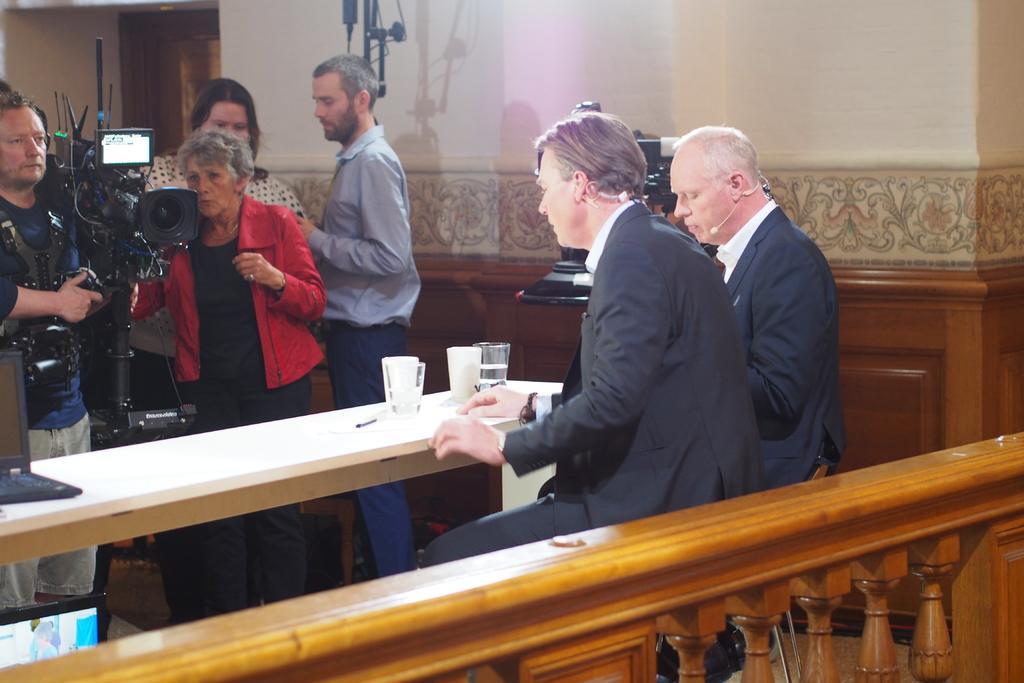In one or two sentences, can you explain what this image depicts? In the foreground of this image, on the bottom, there is a wooden railing. In the middle, there are two men wearing suits and sitting on the chairs and there is a table in front them on which there are glasses and a laptop. On the left bottom, there is a screen of a laptop. In the background, there are persons standing, a camera, wall and another camera in the middle behind the persons and a stand. 